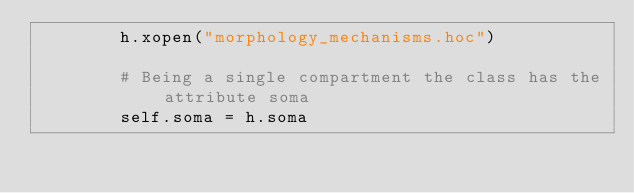<code> <loc_0><loc_0><loc_500><loc_500><_Python_>        h.xopen("morphology_mechanisms.hoc")

        # Being a single compartment the class has the attribute soma
        self.soma = h.soma

</code> 